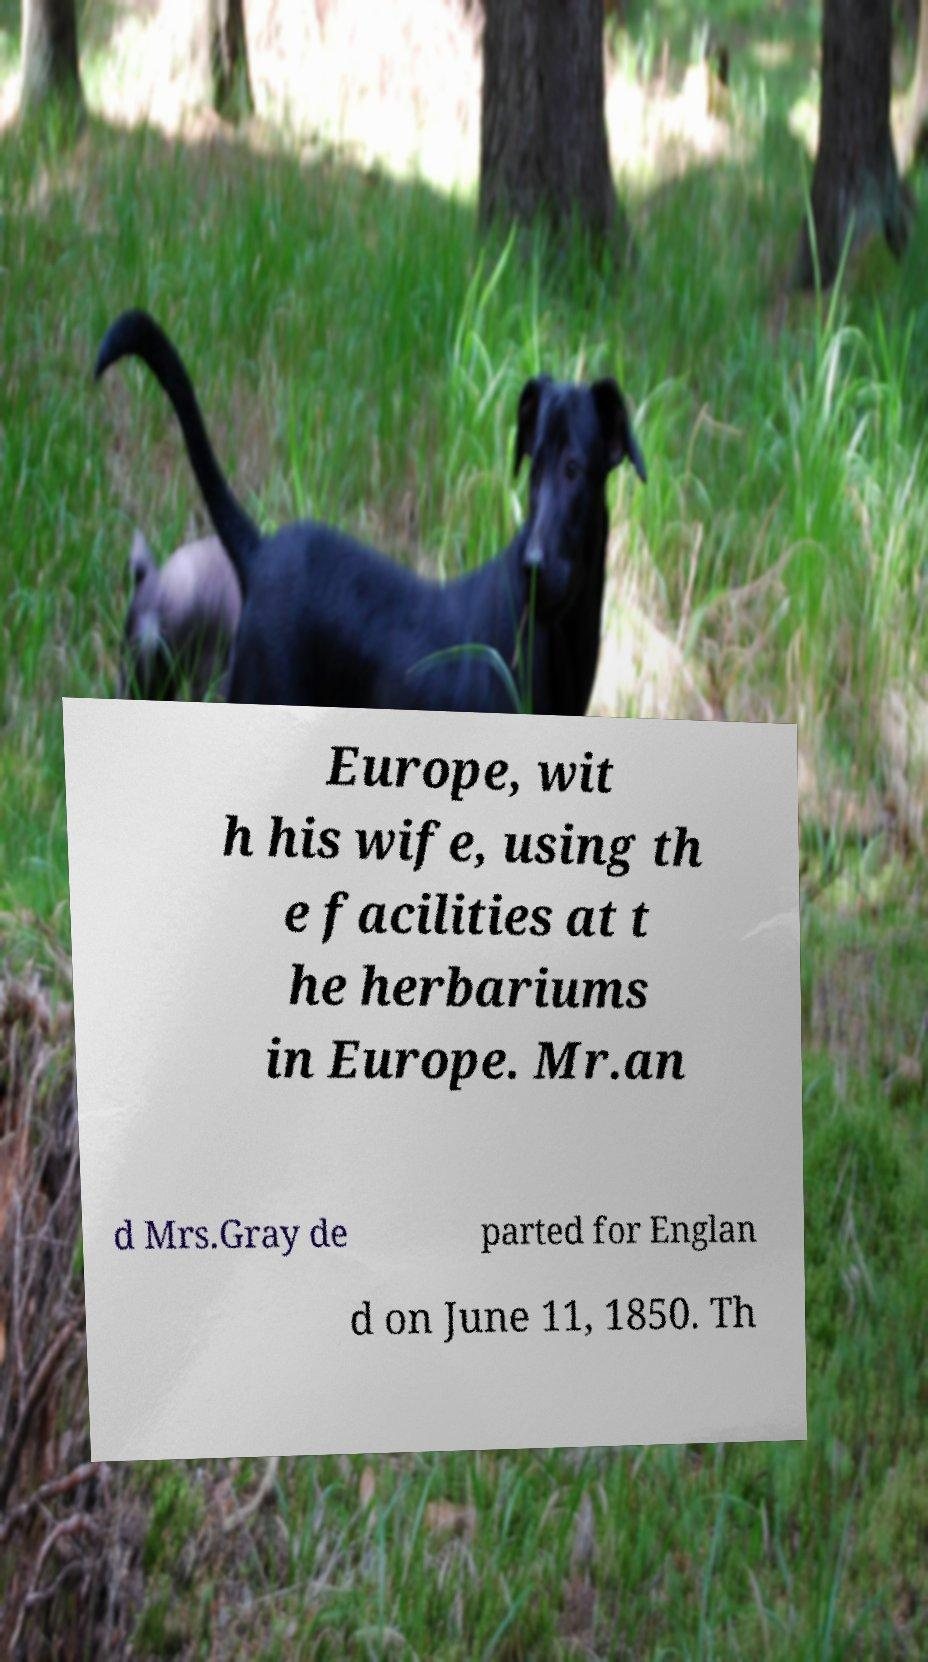I need the written content from this picture converted into text. Can you do that? Europe, wit h his wife, using th e facilities at t he herbariums in Europe. Mr.an d Mrs.Gray de parted for Englan d on June 11, 1850. Th 